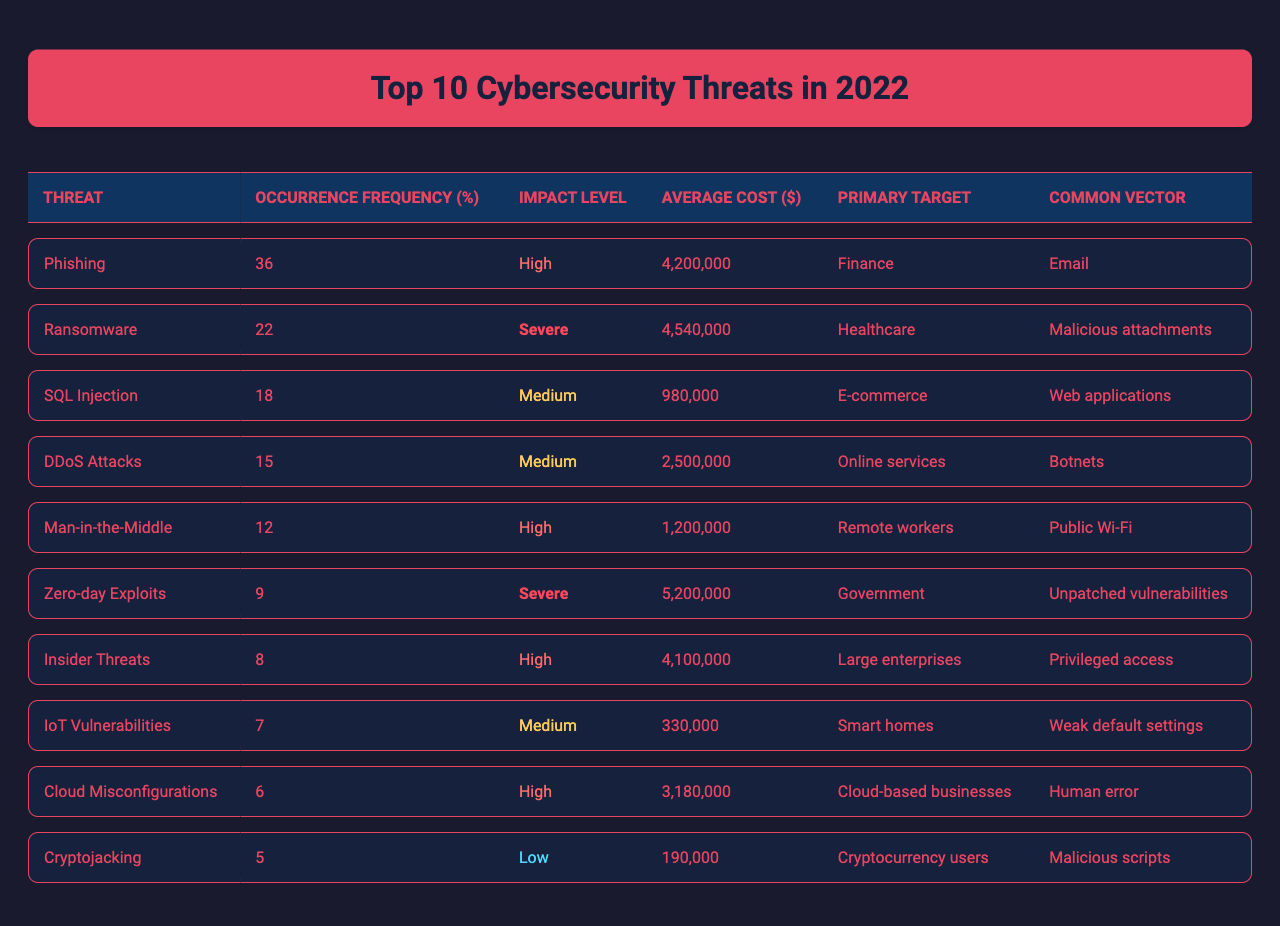What is the highest occurrence frequency among the listed cybersecurity threats? The highest occurrence frequency can be found by comparing the values in the "Occurrence Frequency" column. Phishing has the highest frequency at 36.
Answer: 36 Which threat has the highest average cost, and what is that cost? The highest average cost can be found by reviewing the "Average Cost" column. Ransomware has the highest average cost at $4,540,000.
Answer: $4,540,000 How many threats have an impact level classified as "Severe"? By checking the "Impact Level" column, Zero-day Exploits and Ransomware are both classified as "Severe," totaling two threats.
Answer: 2 What is the average occurrence frequency of the threats listed in the table? To find the average, sum the occurrence frequencies (36 + 22 + 18 + 15 + 12 + 9 + 8 + 7 + 6 + 5 = 138) and divide by the total number of threats, 10. Thus, the average occurrence frequency is 138/10 = 13.8.
Answer: 13.8 Which cybersecurity threat targets the finance sector? By scanning the "Primary Target" column, Phishing is identified as the threat targeting the finance sector.
Answer: Phishing What is the impact level of the threat with the second-highest occurrence frequency? The second-highest occurrence frequency is Ransomware, which is classified as "Severe." This can be confirmed by finding the threat with a frequency of 22.
Answer: Severe Which threat has the lowest occurrence frequency and what is that frequency? The lowest occurrence frequency can be identified by checking the "Occurrence Frequency" column, which shows Cryptojacking with a frequency of 5.
Answer: 5 Calculate the total average cost of all cybersecurity threats listed. To calculate the total average cost, sum up the costs ($4,200,000 + $4,540,000 + $980,000 + $2,500,000 + $1,200,000 + $5,200,000 + $4,100,000 + $330,000 + $3,180,000 + $190,000 = $27,920,000). Thus, the total average cost is $27,920,000.
Answer: $27,920,000 Is there a threat that specifically targets government entities? Checking the "Primary Target" column, Zero-day Exploits is identified as targeting government entities, so the answer is yes.
Answer: Yes Which two threats have the same impact level, and what is that level? By examining the "Impact Level" column, both Phishing and Man-in-the-Middle threats share the "High" impact level.
Answer: High 